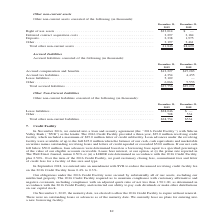According to A10 Networks's financial document, What is the total other non-current liabilities as at 31 December 2018? According to the financial document, $534 (in thousands). The relevant text states: "Lease liabilities . $28,046 $ — Other . 708 534..." Also, What is the total other non-current liabilities as at 31 December 2019? According to the financial document, $28,754 (in thousands). The relevant text states: "Total other non-current liabilities. . $28,754 $534..." Also, What is the lease liability as at 31 December 2019? According to the financial document, $28,046 (in thousands). The relevant text states: "Lease liabilities . $28,046 $ — Other . 708 534..." Also, can you calculate: What is the percentage change in total other non-current liabilities between 2018 and 2019? To answer this question, I need to perform calculations using the financial data. The calculation is: (28,754 - 534)/534 , which equals 5284.64 (percentage). This is based on the information: "Total other non-current liabilities. . $28,754 $534 Lease liabilities . $28,046 $ — Other . 708 534..." The key data points involved are: 28,754, 534. Also, can you calculate: What is the sum of other liabilities in 2019 and 2018? Based on the calculation: 708 + 534 , the result is 1242 (in thousands). This is based on the information: "Lease liabilities . $28,046 $ — Other . 708 534 Lease liabilities . $28,046 $ — Other . 708 534..." The key data points involved are: 534, 708. Also, can you calculate: What is the total non-current liabilities between 2018 to 2019? Based on the calculation: 28,754+534, the result is 29288 (in thousands). This is based on the information: "Total other non-current liabilities. . $28,754 $534 Lease liabilities . $28,046 $ — Other . 708 534..." The key data points involved are: 28,754, 534. 